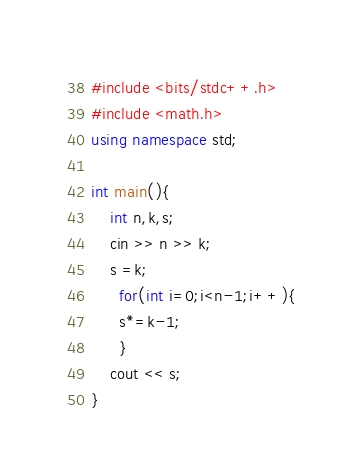<code> <loc_0><loc_0><loc_500><loc_500><_C++_>#include <bits/stdc++.h>
#include <math.h>
using namespace std;

int main(){
	int n,k,s;
  	cin >> n >> k;
  	s =k;
      for(int i=0;i<n-1;i++){
      s*=k-1;
      }
  	cout << s;
}</code> 